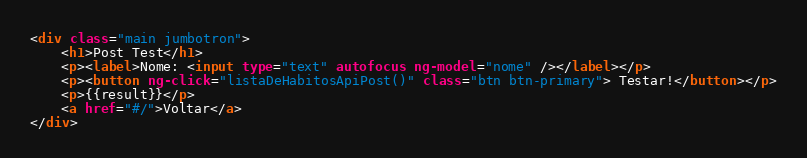Convert code to text. <code><loc_0><loc_0><loc_500><loc_500><_HTML_><div class="main jumbotron">
    <h1>Post Test</h1>
    <p><label>Nome: <input type="text" autofocus ng-model="nome" /></label></p>
    <p><button ng-click="listaDeHabitosApiPost()" class="btn btn-primary"> Testar!</button></p>
    <p>{{result}}</p>
    <a href="#/">Voltar</a>
</div></code> 